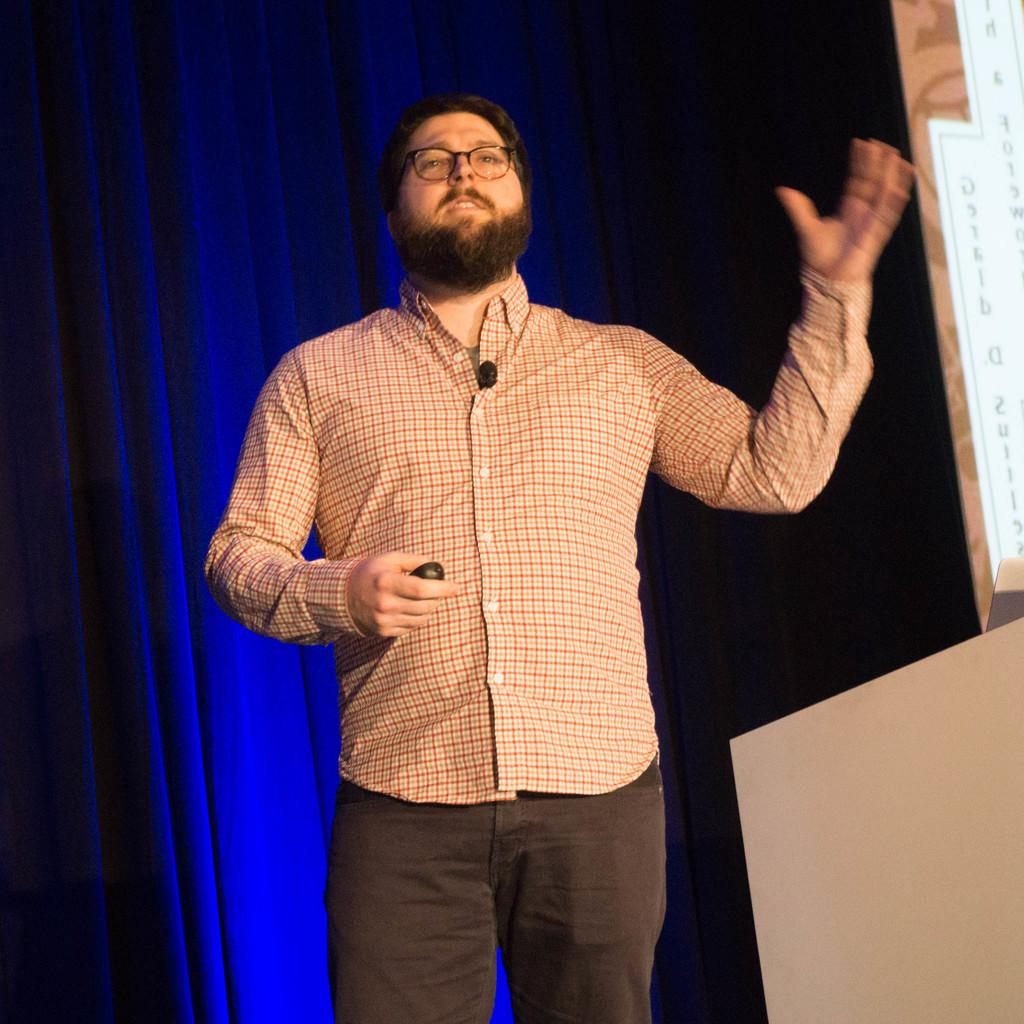Who is present in the image? There is a man in the image. What can be observed about the man's appearance? The man is wearing glasses (specs). What is the man holding in his hand? The man is holding something in his hand, but the specific object cannot be determined from the facts provided. What can be seen in the background of the image? There is a curtain in the background of the image. What is written or displayed on the right side of the image? There is a board with text on the right side of the image. Can you describe the frog sitting on the man's shoulder in the image? There is no frog present in the image; only the man, his glasses, and the object he is holding can be observed. What type of rain is depicted in the image? There is no rain present in the image; it is an indoor scene with a man, glasses, an unspecified object, a curtain, and a board with text. 